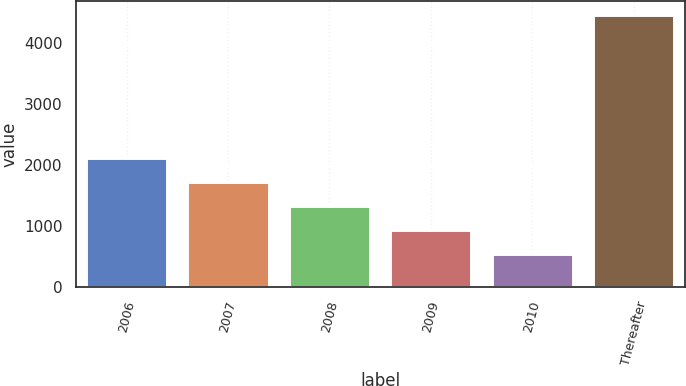Convert chart to OTSL. <chart><loc_0><loc_0><loc_500><loc_500><bar_chart><fcel>2006<fcel>2007<fcel>2008<fcel>2009<fcel>2010<fcel>Thereafter<nl><fcel>2110.4<fcel>1718.8<fcel>1327.2<fcel>935.6<fcel>544<fcel>4460<nl></chart> 